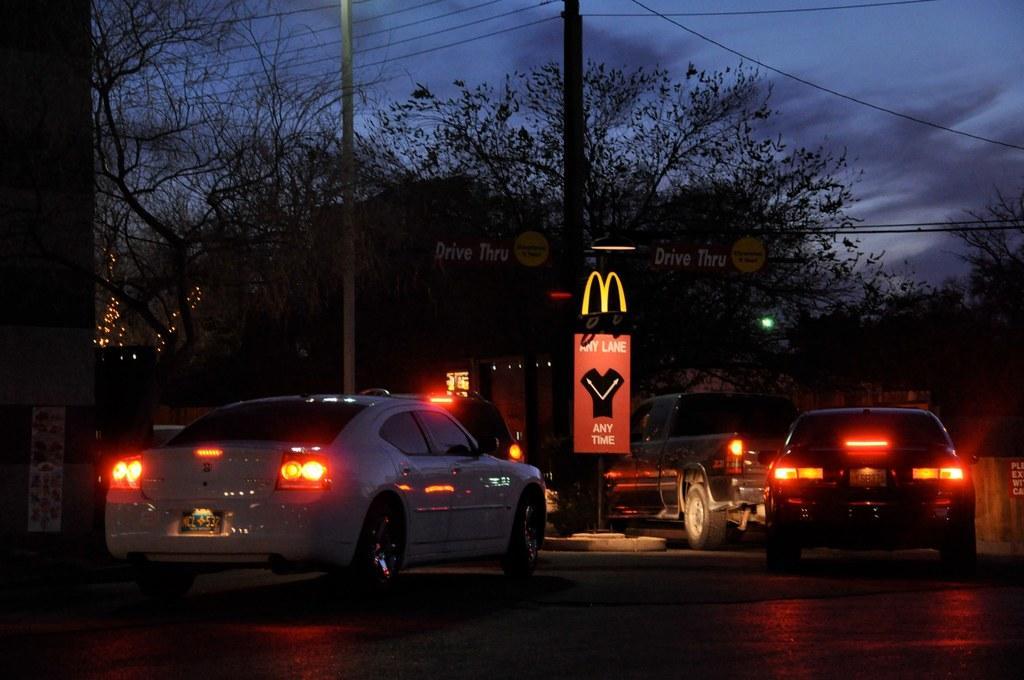Please provide a concise description of this image. As we can see in the image there are trees, cars, banner and on the top there is a sky. 